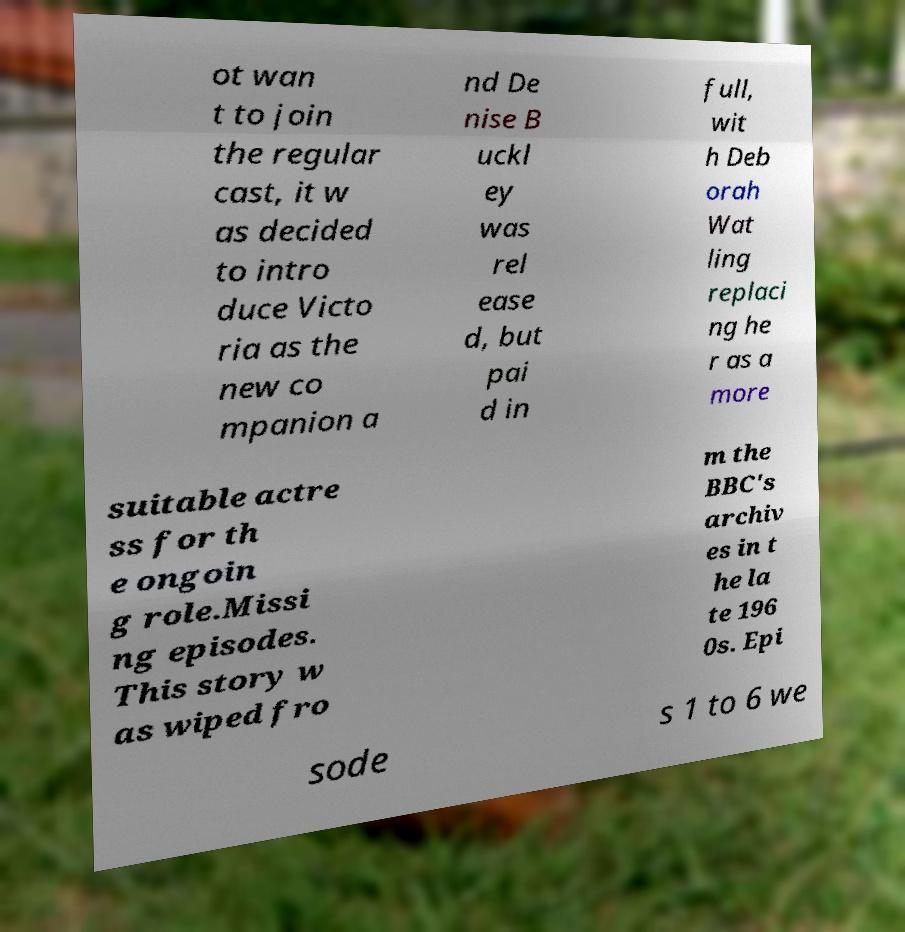I need the written content from this picture converted into text. Can you do that? ot wan t to join the regular cast, it w as decided to intro duce Victo ria as the new co mpanion a nd De nise B uckl ey was rel ease d, but pai d in full, wit h Deb orah Wat ling replaci ng he r as a more suitable actre ss for th e ongoin g role.Missi ng episodes. This story w as wiped fro m the BBC's archiv es in t he la te 196 0s. Epi sode s 1 to 6 we 